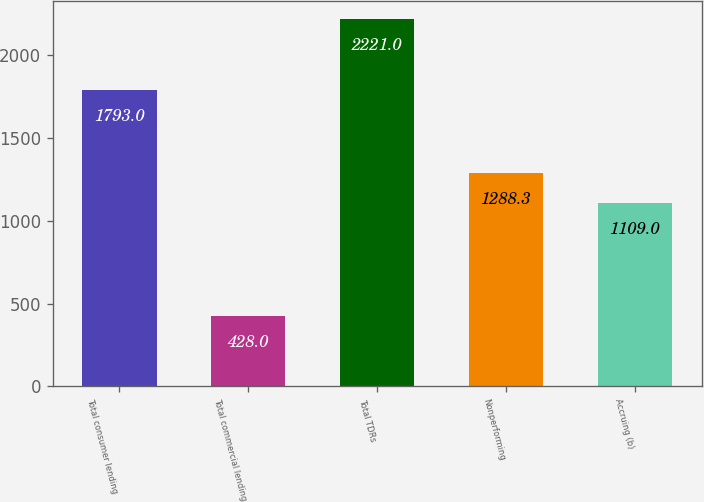Convert chart. <chart><loc_0><loc_0><loc_500><loc_500><bar_chart><fcel>Total consumer lending<fcel>Total commercial lending<fcel>Total TDRs<fcel>Nonperforming<fcel>Accruing (b)<nl><fcel>1793<fcel>428<fcel>2221<fcel>1288.3<fcel>1109<nl></chart> 